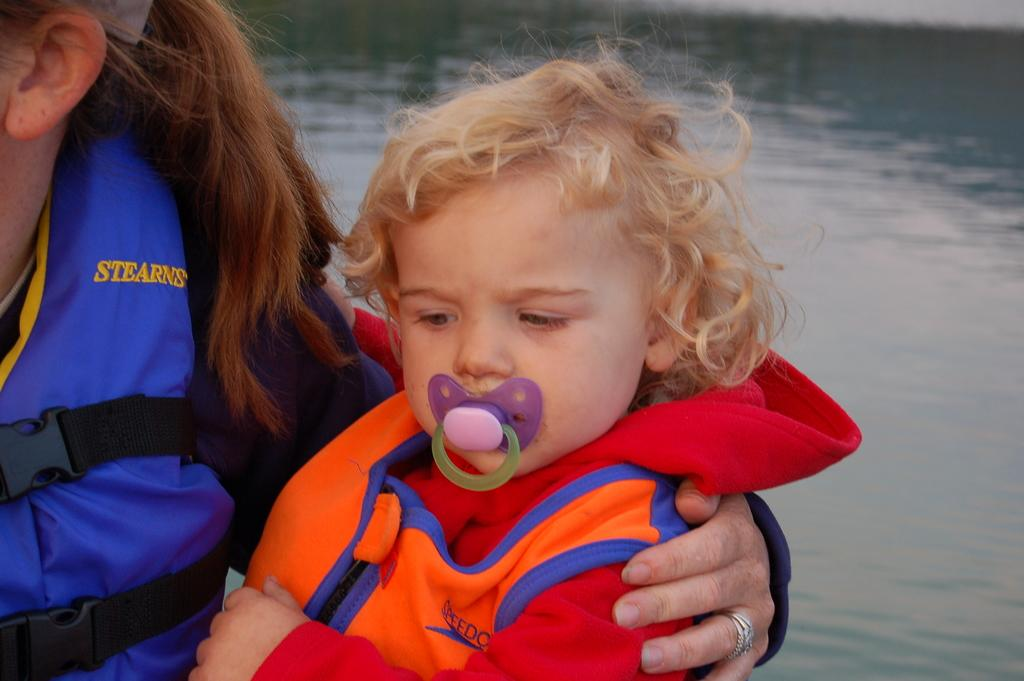Who is the main subject in the image? There is a woman in the image. What is the woman wearing? The woman is wearing a blue jacket. What is the woman holding in the image? The woman is holding a baby. What can be seen in the background of the image? There is water visible in the background of the image. What type of bat is flying over the water in the image? There is no bat present in the image; the background features water, but no animals are visible. 